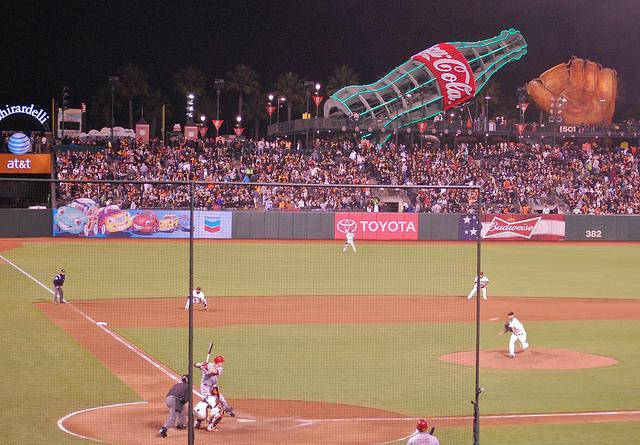How many stars in the Budweiser sign?
Keep it brief. 4. How many fans are watching this baseball game?
Concise answer only. 10000. Which gasoline company is advertised?
Concise answer only. Chevron. 